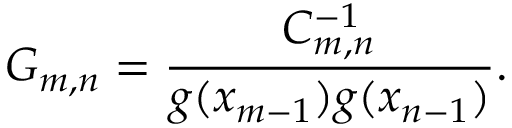<formula> <loc_0><loc_0><loc_500><loc_500>G _ { m , n } = \frac { C _ { m , n } ^ { - 1 } } { g ( x _ { m - 1 } ) g ( x _ { n - 1 } ) } .</formula> 